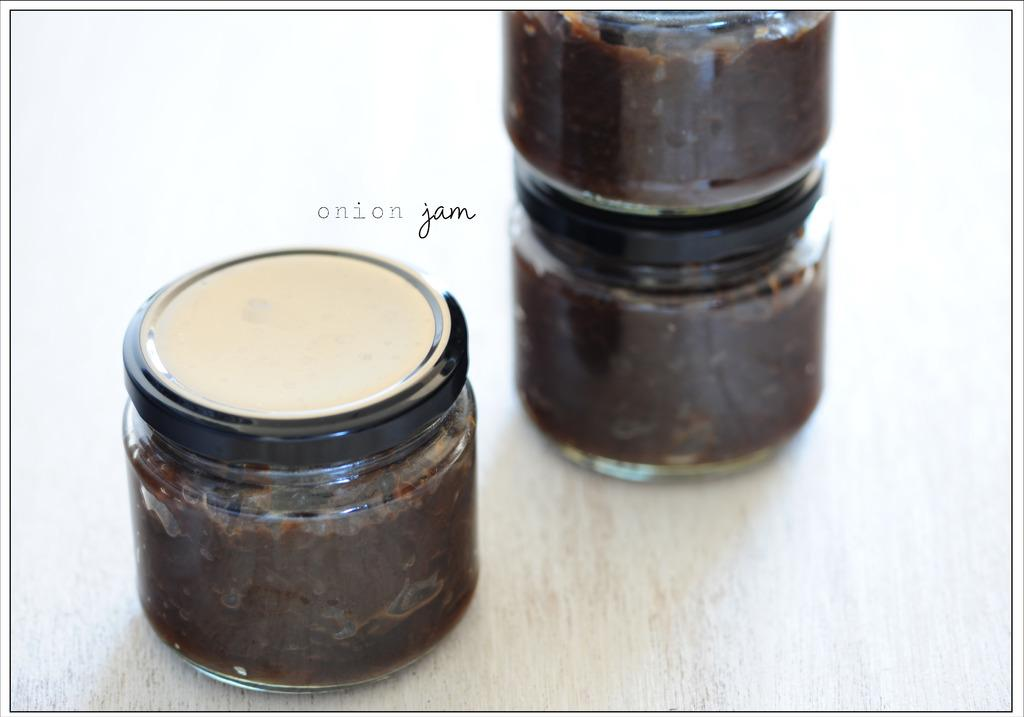Provide a one-sentence caption for the provided image. Three glass jars with lids with a substance inside is sitting on a table with a brand name onion jam. 